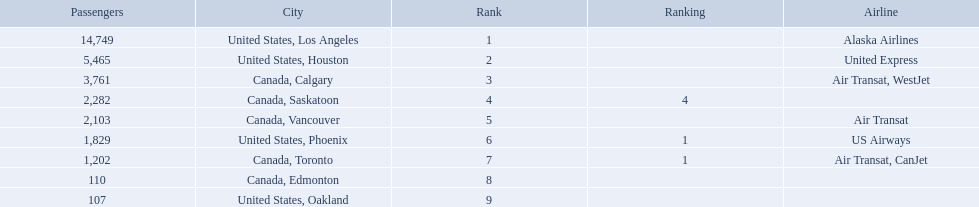What are the cities that are associated with the playa de oro international airport? United States, Los Angeles, United States, Houston, Canada, Calgary, Canada, Saskatoon, Canada, Vancouver, United States, Phoenix, Canada, Toronto, Canada, Edmonton, United States, Oakland. What is uniteed states, los angeles passenger count? 14,749. What other cities passenger count would lead to 19,000 roughly when combined with previous los angeles? Canada, Calgary. Which airport has the least amount of passengers? 107. What airport has 107 passengers? United States, Oakland. 